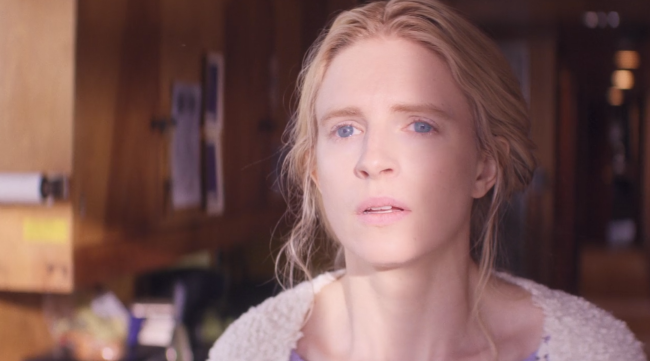What creative scenario involving this woman and her setting can you imagine? Imagine this woman is a secret agent who has just returned to her childhood home after many years. The home looks warm and welcoming, but her serious expression hints at a deeper story. She is revisiting old memories and places, trying to uncover hidden clues her parents left for her decades ago, which could hold the key to unraveling a major conspiracy. As she stands there, lost in thought, she is piecing together fragments of her past with the knowledge she has now, ready to unlock the mysteries that have loomed over her life. 